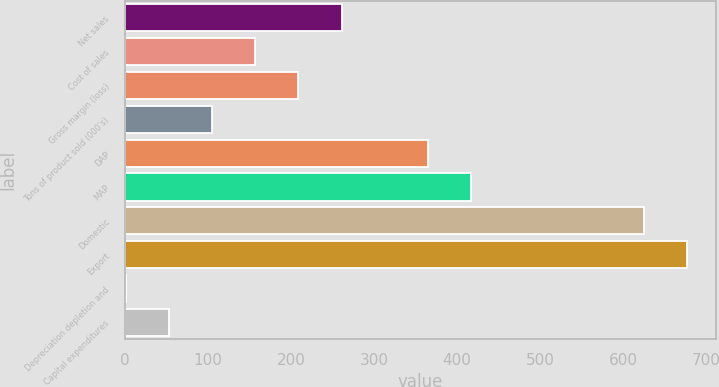Convert chart to OTSL. <chart><loc_0><loc_0><loc_500><loc_500><bar_chart><fcel>Net sales<fcel>Cost of sales<fcel>Gross margin (loss)<fcel>Tons of product sold (000's)<fcel>DAP<fcel>MAP<fcel>Domestic<fcel>Export<fcel>Depreciation depletion and<fcel>Capital expenditures<nl><fcel>261.1<fcel>157.14<fcel>209.12<fcel>105.16<fcel>365.06<fcel>417.04<fcel>624.96<fcel>676.94<fcel>1.2<fcel>53.18<nl></chart> 